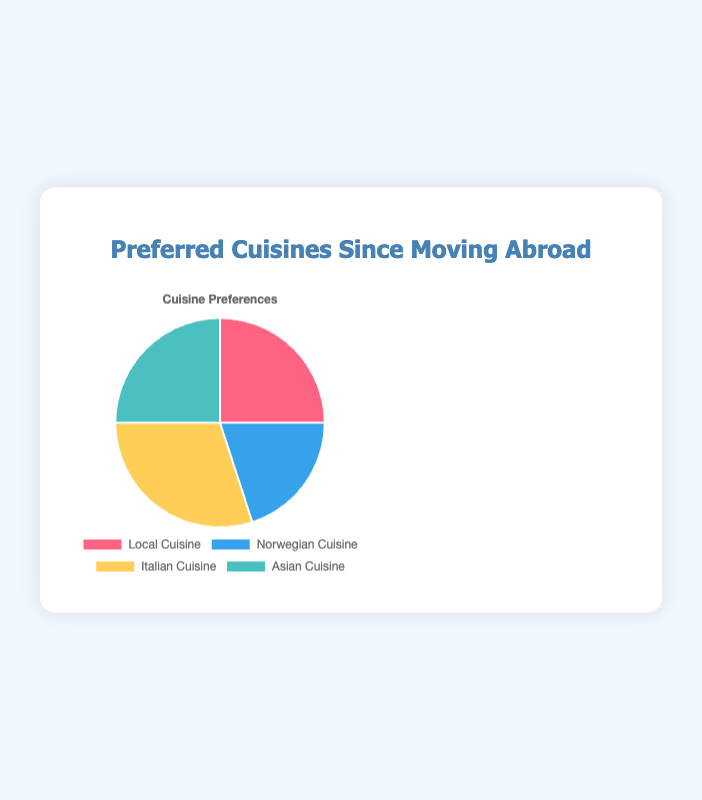What's the most preferred cuisine since moving abroad? The chart shows percentages for each cuisine with Italian Cuisine having the largest share at 30%.
Answer: Italian Cuisine Which two cuisines are equally preferred? The chart shows that both Local Cuisine and Asian Cuisine have an equal share of 25%.
Answer: Local Cuisine and Asian Cuisine By how much percent is Norwegian Cuisine less preferred than Italian Cuisine? Italian Cuisine has a share of 30%, while Norwegian Cuisine has 20%. The difference is 30% - 20% = 10%.
Answer: 10% Which cuisine is least preferred and what is its percentage? The chart indicates that Norwegian Cuisine has the smallest share at 20%.
Answer: Norwegian Cuisine, 20% What is the combined preference percentage for Italian Cuisine and Local Cuisine? Italian Cuisine has 30% and Local Cuisine has 25%. Combined, it's 30% + 25% = 55%.
Answer: 55% Compare the preference between Norwegian Cuisine and Asian Cuisine. Norwegian Cuisine has a preference of 20%, while Asian Cuisine has 25%. 25% is 5 percentage points higher than 20%.
Answer: Asian Cuisine is preferred more by 5 percentage points Which cuisine has a 30% preference, and what color represents it in the pie chart? The chart shows that Italian Cuisine has a 30% preference and is represented by yellow.
Answer: Italian Cuisine, yellow If the preferences were to change so that Norwegian Cuisine increased by 10%, which cuisine would have equal preference to it? Norwegian Cuisine currently stands at 20%. Increasing it by 10% brings it to 30%, making it equal to Italian Cuisine's preference.
Answer: Italian Cuisine What is the difference in preference percentage between the least preferred and most preferred cuisines? The least preferred is Norwegian Cuisine at 20%, and the most preferred is Italian Cuisine at 30%. The difference is 30% - 20% = 10%.
Answer: 10% 